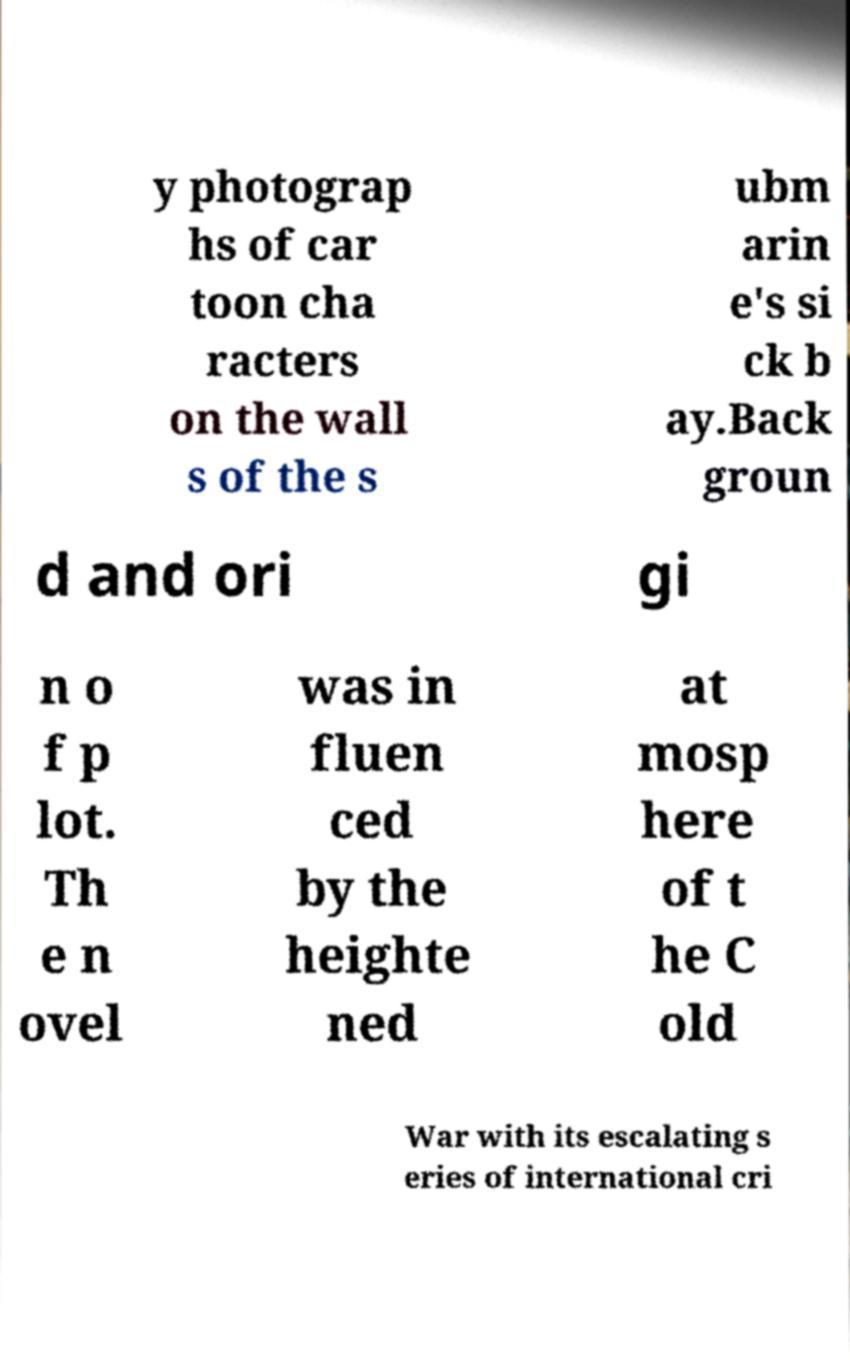Could you extract and type out the text from this image? y photograp hs of car toon cha racters on the wall s of the s ubm arin e's si ck b ay.Back groun d and ori gi n o f p lot. Th e n ovel was in fluen ced by the heighte ned at mosp here of t he C old War with its escalating s eries of international cri 